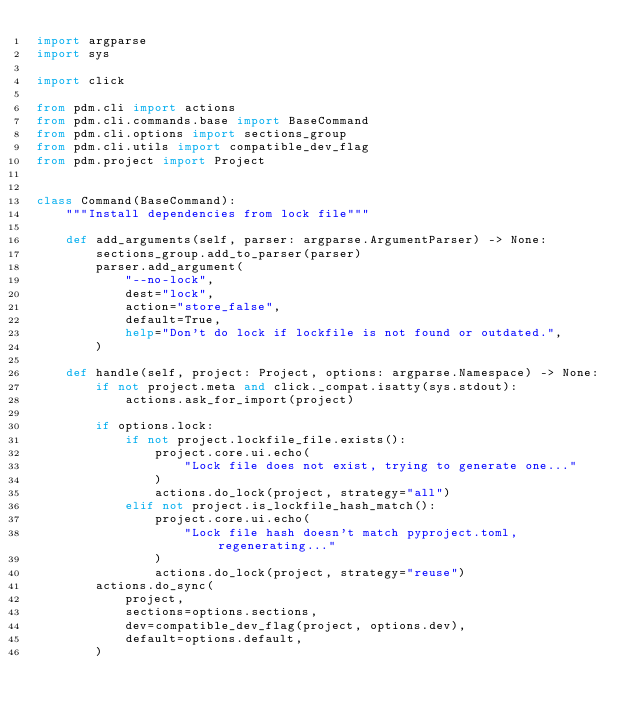<code> <loc_0><loc_0><loc_500><loc_500><_Python_>import argparse
import sys

import click

from pdm.cli import actions
from pdm.cli.commands.base import BaseCommand
from pdm.cli.options import sections_group
from pdm.cli.utils import compatible_dev_flag
from pdm.project import Project


class Command(BaseCommand):
    """Install dependencies from lock file"""

    def add_arguments(self, parser: argparse.ArgumentParser) -> None:
        sections_group.add_to_parser(parser)
        parser.add_argument(
            "--no-lock",
            dest="lock",
            action="store_false",
            default=True,
            help="Don't do lock if lockfile is not found or outdated.",
        )

    def handle(self, project: Project, options: argparse.Namespace) -> None:
        if not project.meta and click._compat.isatty(sys.stdout):
            actions.ask_for_import(project)

        if options.lock:
            if not project.lockfile_file.exists():
                project.core.ui.echo(
                    "Lock file does not exist, trying to generate one..."
                )
                actions.do_lock(project, strategy="all")
            elif not project.is_lockfile_hash_match():
                project.core.ui.echo(
                    "Lock file hash doesn't match pyproject.toml, regenerating..."
                )
                actions.do_lock(project, strategy="reuse")
        actions.do_sync(
            project,
            sections=options.sections,
            dev=compatible_dev_flag(project, options.dev),
            default=options.default,
        )
</code> 